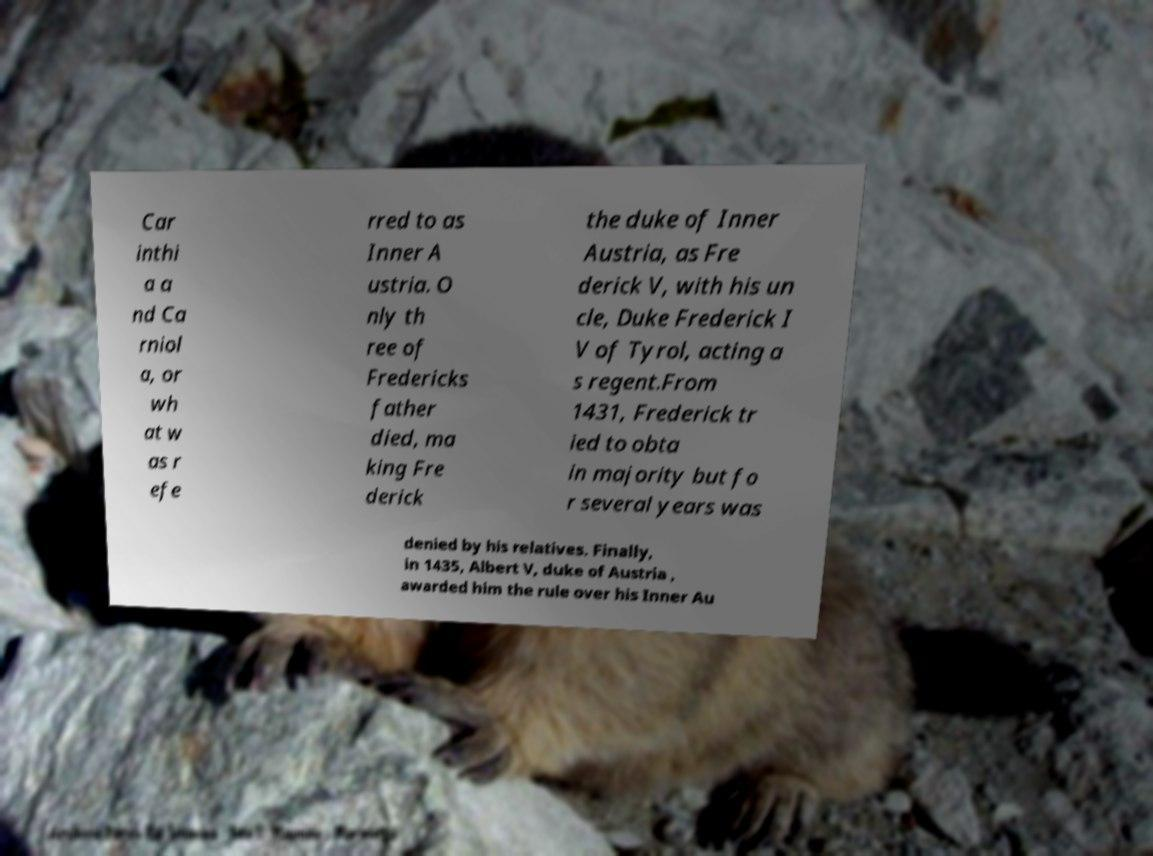Could you extract and type out the text from this image? Car inthi a a nd Ca rniol a, or wh at w as r efe rred to as Inner A ustria. O nly th ree of Fredericks father died, ma king Fre derick the duke of Inner Austria, as Fre derick V, with his un cle, Duke Frederick I V of Tyrol, acting a s regent.From 1431, Frederick tr ied to obta in majority but fo r several years was denied by his relatives. Finally, in 1435, Albert V, duke of Austria , awarded him the rule over his Inner Au 